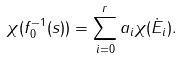<formula> <loc_0><loc_0><loc_500><loc_500>\chi ( f _ { 0 } ^ { - 1 } ( s ) ) = \sum _ { i = 0 } ^ { r } a _ { i } \chi ( \dot { E } _ { i } ) .</formula> 